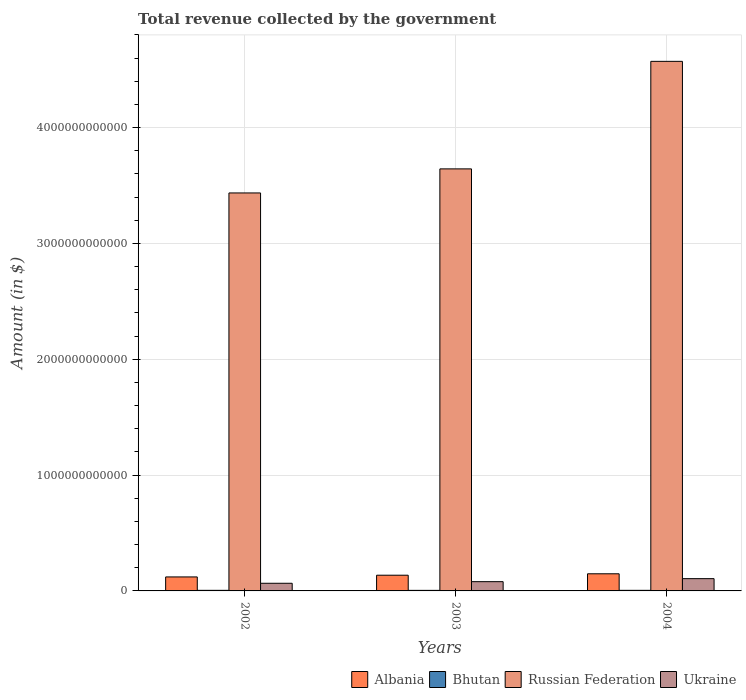How many bars are there on the 2nd tick from the right?
Make the answer very short. 4. What is the total revenue collected by the government in Ukraine in 2002?
Give a very brief answer. 6.60e+1. Across all years, what is the maximum total revenue collected by the government in Ukraine?
Ensure brevity in your answer.  1.06e+11. Across all years, what is the minimum total revenue collected by the government in Russian Federation?
Your answer should be compact. 3.44e+12. In which year was the total revenue collected by the government in Ukraine maximum?
Offer a very short reply. 2004. What is the total total revenue collected by the government in Russian Federation in the graph?
Ensure brevity in your answer.  1.17e+13. What is the difference between the total revenue collected by the government in Bhutan in 2003 and that in 2004?
Provide a short and direct response. -2.58e+08. What is the difference between the total revenue collected by the government in Albania in 2003 and the total revenue collected by the government in Ukraine in 2002?
Offer a terse response. 6.96e+1. What is the average total revenue collected by the government in Bhutan per year?
Your answer should be compact. 4.93e+09. In the year 2004, what is the difference between the total revenue collected by the government in Ukraine and total revenue collected by the government in Bhutan?
Keep it short and to the point. 1.01e+11. What is the ratio of the total revenue collected by the government in Ukraine in 2002 to that in 2003?
Ensure brevity in your answer.  0.83. Is the total revenue collected by the government in Ukraine in 2003 less than that in 2004?
Offer a very short reply. Yes. Is the difference between the total revenue collected by the government in Ukraine in 2002 and 2004 greater than the difference between the total revenue collected by the government in Bhutan in 2002 and 2004?
Ensure brevity in your answer.  No. What is the difference between the highest and the second highest total revenue collected by the government in Ukraine?
Provide a short and direct response. 2.61e+1. What is the difference between the highest and the lowest total revenue collected by the government in Bhutan?
Your answer should be compact. 2.97e+08. In how many years, is the total revenue collected by the government in Bhutan greater than the average total revenue collected by the government in Bhutan taken over all years?
Your response must be concise. 2. Is the sum of the total revenue collected by the government in Ukraine in 2002 and 2004 greater than the maximum total revenue collected by the government in Russian Federation across all years?
Provide a short and direct response. No. What does the 1st bar from the left in 2002 represents?
Offer a terse response. Albania. What does the 3rd bar from the right in 2004 represents?
Provide a short and direct response. Bhutan. Is it the case that in every year, the sum of the total revenue collected by the government in Bhutan and total revenue collected by the government in Russian Federation is greater than the total revenue collected by the government in Albania?
Provide a succinct answer. Yes. How many bars are there?
Offer a terse response. 12. What is the difference between two consecutive major ticks on the Y-axis?
Keep it short and to the point. 1.00e+12. Does the graph contain any zero values?
Offer a very short reply. No. Does the graph contain grids?
Provide a succinct answer. Yes. How many legend labels are there?
Ensure brevity in your answer.  4. How are the legend labels stacked?
Offer a terse response. Horizontal. What is the title of the graph?
Provide a succinct answer. Total revenue collected by the government. Does "Mongolia" appear as one of the legend labels in the graph?
Your answer should be compact. No. What is the label or title of the Y-axis?
Give a very brief answer. Amount (in $). What is the Amount (in $) of Albania in 2002?
Offer a very short reply. 1.21e+11. What is the Amount (in $) in Bhutan in 2002?
Offer a very short reply. 5.04e+09. What is the Amount (in $) in Russian Federation in 2002?
Make the answer very short. 3.44e+12. What is the Amount (in $) of Ukraine in 2002?
Provide a short and direct response. 6.60e+1. What is the Amount (in $) of Albania in 2003?
Make the answer very short. 1.36e+11. What is the Amount (in $) in Bhutan in 2003?
Give a very brief answer. 4.75e+09. What is the Amount (in $) of Russian Federation in 2003?
Your response must be concise. 3.64e+12. What is the Amount (in $) of Ukraine in 2003?
Provide a succinct answer. 7.99e+1. What is the Amount (in $) of Albania in 2004?
Your answer should be compact. 1.48e+11. What is the Amount (in $) of Bhutan in 2004?
Your response must be concise. 5.00e+09. What is the Amount (in $) of Russian Federation in 2004?
Your answer should be very brief. 4.57e+12. What is the Amount (in $) of Ukraine in 2004?
Your answer should be compact. 1.06e+11. Across all years, what is the maximum Amount (in $) in Albania?
Provide a succinct answer. 1.48e+11. Across all years, what is the maximum Amount (in $) of Bhutan?
Ensure brevity in your answer.  5.04e+09. Across all years, what is the maximum Amount (in $) in Russian Federation?
Provide a succinct answer. 4.57e+12. Across all years, what is the maximum Amount (in $) in Ukraine?
Offer a very short reply. 1.06e+11. Across all years, what is the minimum Amount (in $) of Albania?
Offer a very short reply. 1.21e+11. Across all years, what is the minimum Amount (in $) in Bhutan?
Provide a short and direct response. 4.75e+09. Across all years, what is the minimum Amount (in $) of Russian Federation?
Your response must be concise. 3.44e+12. Across all years, what is the minimum Amount (in $) of Ukraine?
Keep it short and to the point. 6.60e+1. What is the total Amount (in $) of Albania in the graph?
Your response must be concise. 4.04e+11. What is the total Amount (in $) of Bhutan in the graph?
Provide a succinct answer. 1.48e+1. What is the total Amount (in $) of Russian Federation in the graph?
Keep it short and to the point. 1.17e+13. What is the total Amount (in $) in Ukraine in the graph?
Your answer should be very brief. 2.52e+11. What is the difference between the Amount (in $) of Albania in 2002 and that in 2003?
Provide a succinct answer. -1.49e+1. What is the difference between the Amount (in $) in Bhutan in 2002 and that in 2003?
Your answer should be compact. 2.97e+08. What is the difference between the Amount (in $) in Russian Federation in 2002 and that in 2003?
Offer a very short reply. -2.08e+11. What is the difference between the Amount (in $) of Ukraine in 2002 and that in 2003?
Provide a succinct answer. -1.39e+1. What is the difference between the Amount (in $) of Albania in 2002 and that in 2004?
Ensure brevity in your answer.  -2.71e+1. What is the difference between the Amount (in $) in Bhutan in 2002 and that in 2004?
Keep it short and to the point. 3.94e+07. What is the difference between the Amount (in $) in Russian Federation in 2002 and that in 2004?
Provide a short and direct response. -1.14e+12. What is the difference between the Amount (in $) in Ukraine in 2002 and that in 2004?
Offer a terse response. -4.00e+1. What is the difference between the Amount (in $) in Albania in 2003 and that in 2004?
Give a very brief answer. -1.22e+1. What is the difference between the Amount (in $) of Bhutan in 2003 and that in 2004?
Give a very brief answer. -2.58e+08. What is the difference between the Amount (in $) of Russian Federation in 2003 and that in 2004?
Make the answer very short. -9.28e+11. What is the difference between the Amount (in $) in Ukraine in 2003 and that in 2004?
Offer a very short reply. -2.61e+1. What is the difference between the Amount (in $) in Albania in 2002 and the Amount (in $) in Bhutan in 2003?
Provide a short and direct response. 1.16e+11. What is the difference between the Amount (in $) of Albania in 2002 and the Amount (in $) of Russian Federation in 2003?
Your answer should be compact. -3.52e+12. What is the difference between the Amount (in $) in Albania in 2002 and the Amount (in $) in Ukraine in 2003?
Give a very brief answer. 4.09e+1. What is the difference between the Amount (in $) in Bhutan in 2002 and the Amount (in $) in Russian Federation in 2003?
Ensure brevity in your answer.  -3.64e+12. What is the difference between the Amount (in $) of Bhutan in 2002 and the Amount (in $) of Ukraine in 2003?
Your answer should be compact. -7.49e+1. What is the difference between the Amount (in $) of Russian Federation in 2002 and the Amount (in $) of Ukraine in 2003?
Make the answer very short. 3.36e+12. What is the difference between the Amount (in $) of Albania in 2002 and the Amount (in $) of Bhutan in 2004?
Offer a very short reply. 1.16e+11. What is the difference between the Amount (in $) in Albania in 2002 and the Amount (in $) in Russian Federation in 2004?
Provide a short and direct response. -4.45e+12. What is the difference between the Amount (in $) in Albania in 2002 and the Amount (in $) in Ukraine in 2004?
Offer a terse response. 1.48e+1. What is the difference between the Amount (in $) of Bhutan in 2002 and the Amount (in $) of Russian Federation in 2004?
Give a very brief answer. -4.57e+12. What is the difference between the Amount (in $) of Bhutan in 2002 and the Amount (in $) of Ukraine in 2004?
Keep it short and to the point. -1.01e+11. What is the difference between the Amount (in $) of Russian Federation in 2002 and the Amount (in $) of Ukraine in 2004?
Give a very brief answer. 3.33e+12. What is the difference between the Amount (in $) of Albania in 2003 and the Amount (in $) of Bhutan in 2004?
Your answer should be very brief. 1.31e+11. What is the difference between the Amount (in $) of Albania in 2003 and the Amount (in $) of Russian Federation in 2004?
Your response must be concise. -4.44e+12. What is the difference between the Amount (in $) in Albania in 2003 and the Amount (in $) in Ukraine in 2004?
Offer a terse response. 2.96e+1. What is the difference between the Amount (in $) in Bhutan in 2003 and the Amount (in $) in Russian Federation in 2004?
Make the answer very short. -4.57e+12. What is the difference between the Amount (in $) in Bhutan in 2003 and the Amount (in $) in Ukraine in 2004?
Provide a succinct answer. -1.01e+11. What is the difference between the Amount (in $) of Russian Federation in 2003 and the Amount (in $) of Ukraine in 2004?
Make the answer very short. 3.54e+12. What is the average Amount (in $) of Albania per year?
Provide a succinct answer. 1.35e+11. What is the average Amount (in $) in Bhutan per year?
Give a very brief answer. 4.93e+09. What is the average Amount (in $) in Russian Federation per year?
Keep it short and to the point. 3.88e+12. What is the average Amount (in $) of Ukraine per year?
Your response must be concise. 8.40e+1. In the year 2002, what is the difference between the Amount (in $) of Albania and Amount (in $) of Bhutan?
Your response must be concise. 1.16e+11. In the year 2002, what is the difference between the Amount (in $) in Albania and Amount (in $) in Russian Federation?
Your answer should be compact. -3.32e+12. In the year 2002, what is the difference between the Amount (in $) in Albania and Amount (in $) in Ukraine?
Make the answer very short. 5.48e+1. In the year 2002, what is the difference between the Amount (in $) in Bhutan and Amount (in $) in Russian Federation?
Make the answer very short. -3.43e+12. In the year 2002, what is the difference between the Amount (in $) of Bhutan and Amount (in $) of Ukraine?
Your answer should be compact. -6.10e+1. In the year 2002, what is the difference between the Amount (in $) of Russian Federation and Amount (in $) of Ukraine?
Give a very brief answer. 3.37e+12. In the year 2003, what is the difference between the Amount (in $) in Albania and Amount (in $) in Bhutan?
Provide a short and direct response. 1.31e+11. In the year 2003, what is the difference between the Amount (in $) of Albania and Amount (in $) of Russian Federation?
Offer a terse response. -3.51e+12. In the year 2003, what is the difference between the Amount (in $) of Albania and Amount (in $) of Ukraine?
Make the answer very short. 5.57e+1. In the year 2003, what is the difference between the Amount (in $) in Bhutan and Amount (in $) in Russian Federation?
Your answer should be compact. -3.64e+12. In the year 2003, what is the difference between the Amount (in $) of Bhutan and Amount (in $) of Ukraine?
Offer a very short reply. -7.52e+1. In the year 2003, what is the difference between the Amount (in $) in Russian Federation and Amount (in $) in Ukraine?
Offer a very short reply. 3.56e+12. In the year 2004, what is the difference between the Amount (in $) in Albania and Amount (in $) in Bhutan?
Your answer should be very brief. 1.43e+11. In the year 2004, what is the difference between the Amount (in $) in Albania and Amount (in $) in Russian Federation?
Provide a succinct answer. -4.42e+12. In the year 2004, what is the difference between the Amount (in $) of Albania and Amount (in $) of Ukraine?
Your answer should be very brief. 4.19e+1. In the year 2004, what is the difference between the Amount (in $) of Bhutan and Amount (in $) of Russian Federation?
Your answer should be very brief. -4.57e+12. In the year 2004, what is the difference between the Amount (in $) in Bhutan and Amount (in $) in Ukraine?
Your answer should be very brief. -1.01e+11. In the year 2004, what is the difference between the Amount (in $) of Russian Federation and Amount (in $) of Ukraine?
Your answer should be very brief. 4.47e+12. What is the ratio of the Amount (in $) of Albania in 2002 to that in 2003?
Give a very brief answer. 0.89. What is the ratio of the Amount (in $) of Bhutan in 2002 to that in 2003?
Your answer should be compact. 1.06. What is the ratio of the Amount (in $) of Russian Federation in 2002 to that in 2003?
Provide a succinct answer. 0.94. What is the ratio of the Amount (in $) of Ukraine in 2002 to that in 2003?
Give a very brief answer. 0.83. What is the ratio of the Amount (in $) in Albania in 2002 to that in 2004?
Keep it short and to the point. 0.82. What is the ratio of the Amount (in $) of Bhutan in 2002 to that in 2004?
Provide a short and direct response. 1.01. What is the ratio of the Amount (in $) in Russian Federation in 2002 to that in 2004?
Your answer should be very brief. 0.75. What is the ratio of the Amount (in $) of Ukraine in 2002 to that in 2004?
Offer a terse response. 0.62. What is the ratio of the Amount (in $) in Albania in 2003 to that in 2004?
Your answer should be very brief. 0.92. What is the ratio of the Amount (in $) of Bhutan in 2003 to that in 2004?
Ensure brevity in your answer.  0.95. What is the ratio of the Amount (in $) of Russian Federation in 2003 to that in 2004?
Provide a succinct answer. 0.8. What is the ratio of the Amount (in $) in Ukraine in 2003 to that in 2004?
Your response must be concise. 0.75. What is the difference between the highest and the second highest Amount (in $) in Albania?
Your response must be concise. 1.22e+1. What is the difference between the highest and the second highest Amount (in $) of Bhutan?
Provide a short and direct response. 3.94e+07. What is the difference between the highest and the second highest Amount (in $) of Russian Federation?
Offer a terse response. 9.28e+11. What is the difference between the highest and the second highest Amount (in $) of Ukraine?
Provide a succinct answer. 2.61e+1. What is the difference between the highest and the lowest Amount (in $) of Albania?
Offer a terse response. 2.71e+1. What is the difference between the highest and the lowest Amount (in $) of Bhutan?
Make the answer very short. 2.97e+08. What is the difference between the highest and the lowest Amount (in $) of Russian Federation?
Offer a very short reply. 1.14e+12. What is the difference between the highest and the lowest Amount (in $) of Ukraine?
Ensure brevity in your answer.  4.00e+1. 